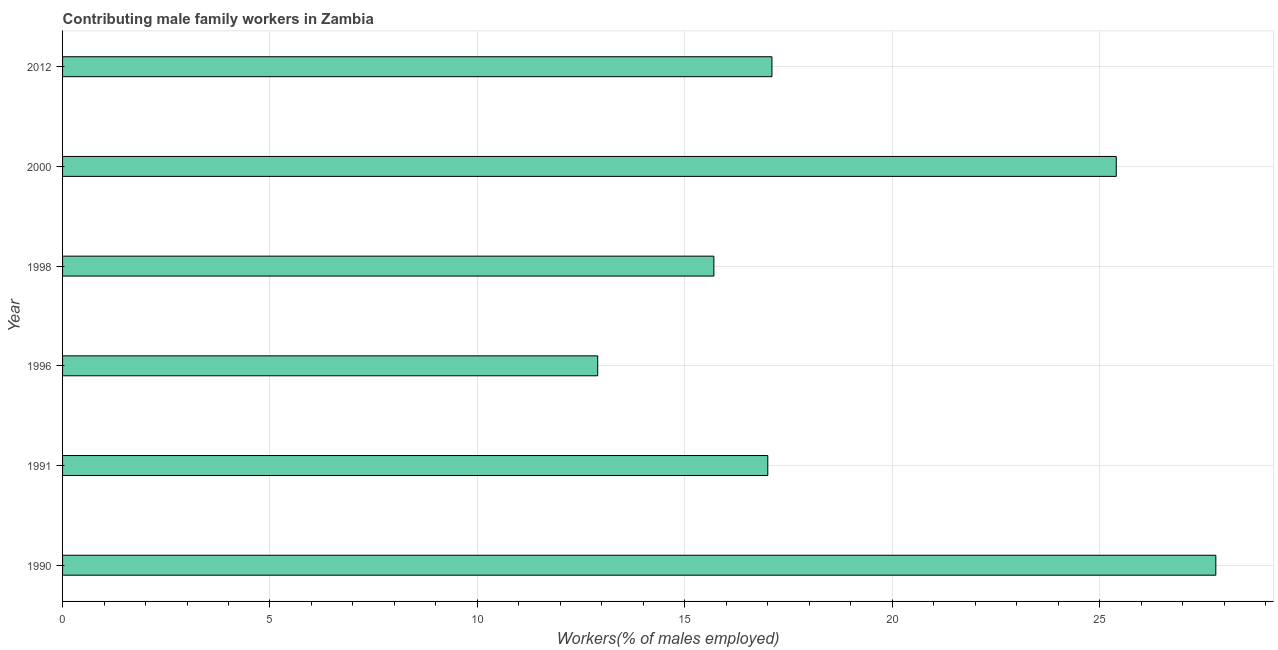What is the title of the graph?
Give a very brief answer. Contributing male family workers in Zambia. What is the label or title of the X-axis?
Offer a terse response. Workers(% of males employed). What is the label or title of the Y-axis?
Offer a very short reply. Year. What is the contributing male family workers in 1998?
Your answer should be very brief. 15.7. Across all years, what is the maximum contributing male family workers?
Your answer should be compact. 27.8. Across all years, what is the minimum contributing male family workers?
Make the answer very short. 12.9. In which year was the contributing male family workers minimum?
Provide a short and direct response. 1996. What is the sum of the contributing male family workers?
Give a very brief answer. 115.9. What is the difference between the contributing male family workers in 1990 and 1998?
Give a very brief answer. 12.1. What is the average contributing male family workers per year?
Provide a short and direct response. 19.32. What is the median contributing male family workers?
Offer a very short reply. 17.05. What is the ratio of the contributing male family workers in 1996 to that in 2012?
Keep it short and to the point. 0.75. Is the difference between the contributing male family workers in 1991 and 2000 greater than the difference between any two years?
Your answer should be compact. No. How many bars are there?
Your answer should be compact. 6. How many years are there in the graph?
Offer a terse response. 6. What is the Workers(% of males employed) in 1990?
Make the answer very short. 27.8. What is the Workers(% of males employed) in 1996?
Provide a short and direct response. 12.9. What is the Workers(% of males employed) of 1998?
Provide a short and direct response. 15.7. What is the Workers(% of males employed) of 2000?
Offer a very short reply. 25.4. What is the Workers(% of males employed) of 2012?
Make the answer very short. 17.1. What is the difference between the Workers(% of males employed) in 1990 and 1991?
Give a very brief answer. 10.8. What is the difference between the Workers(% of males employed) in 1990 and 1998?
Your answer should be compact. 12.1. What is the difference between the Workers(% of males employed) in 1990 and 2012?
Your answer should be very brief. 10.7. What is the difference between the Workers(% of males employed) in 1996 and 1998?
Provide a succinct answer. -2.8. What is the difference between the Workers(% of males employed) in 1996 and 2000?
Ensure brevity in your answer.  -12.5. What is the difference between the Workers(% of males employed) in 1996 and 2012?
Provide a short and direct response. -4.2. What is the difference between the Workers(% of males employed) in 1998 and 2012?
Give a very brief answer. -1.4. What is the difference between the Workers(% of males employed) in 2000 and 2012?
Provide a succinct answer. 8.3. What is the ratio of the Workers(% of males employed) in 1990 to that in 1991?
Your answer should be very brief. 1.64. What is the ratio of the Workers(% of males employed) in 1990 to that in 1996?
Provide a succinct answer. 2.15. What is the ratio of the Workers(% of males employed) in 1990 to that in 1998?
Offer a terse response. 1.77. What is the ratio of the Workers(% of males employed) in 1990 to that in 2000?
Provide a short and direct response. 1.09. What is the ratio of the Workers(% of males employed) in 1990 to that in 2012?
Offer a terse response. 1.63. What is the ratio of the Workers(% of males employed) in 1991 to that in 1996?
Offer a very short reply. 1.32. What is the ratio of the Workers(% of males employed) in 1991 to that in 1998?
Your answer should be compact. 1.08. What is the ratio of the Workers(% of males employed) in 1991 to that in 2000?
Make the answer very short. 0.67. What is the ratio of the Workers(% of males employed) in 1996 to that in 1998?
Offer a very short reply. 0.82. What is the ratio of the Workers(% of males employed) in 1996 to that in 2000?
Make the answer very short. 0.51. What is the ratio of the Workers(% of males employed) in 1996 to that in 2012?
Your answer should be compact. 0.75. What is the ratio of the Workers(% of males employed) in 1998 to that in 2000?
Offer a very short reply. 0.62. What is the ratio of the Workers(% of males employed) in 1998 to that in 2012?
Offer a very short reply. 0.92. What is the ratio of the Workers(% of males employed) in 2000 to that in 2012?
Your answer should be compact. 1.49. 